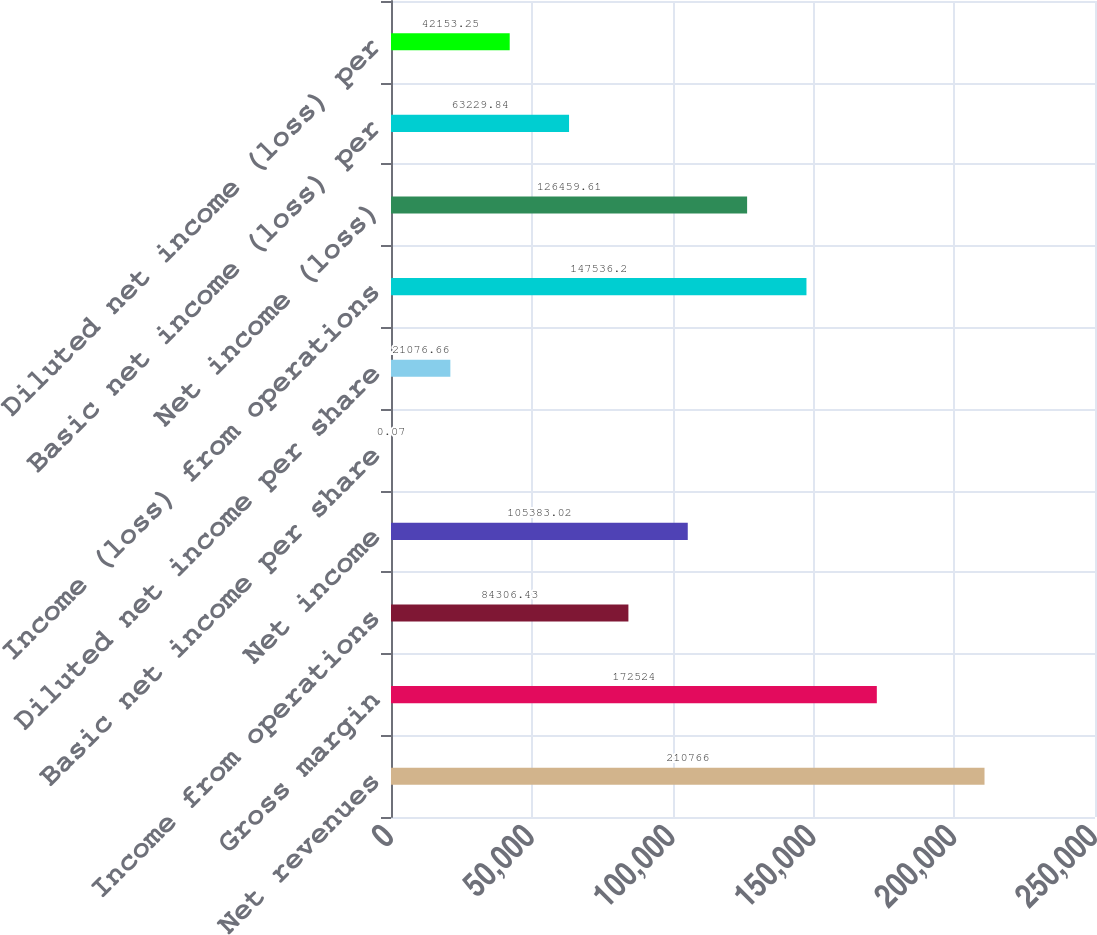<chart> <loc_0><loc_0><loc_500><loc_500><bar_chart><fcel>Net revenues<fcel>Gross margin<fcel>Income from operations<fcel>Net income<fcel>Basic net income per share<fcel>Diluted net income per share<fcel>Income (loss) from operations<fcel>Net income (loss)<fcel>Basic net income (loss) per<fcel>Diluted net income (loss) per<nl><fcel>210766<fcel>172524<fcel>84306.4<fcel>105383<fcel>0.07<fcel>21076.7<fcel>147536<fcel>126460<fcel>63229.8<fcel>42153.2<nl></chart> 